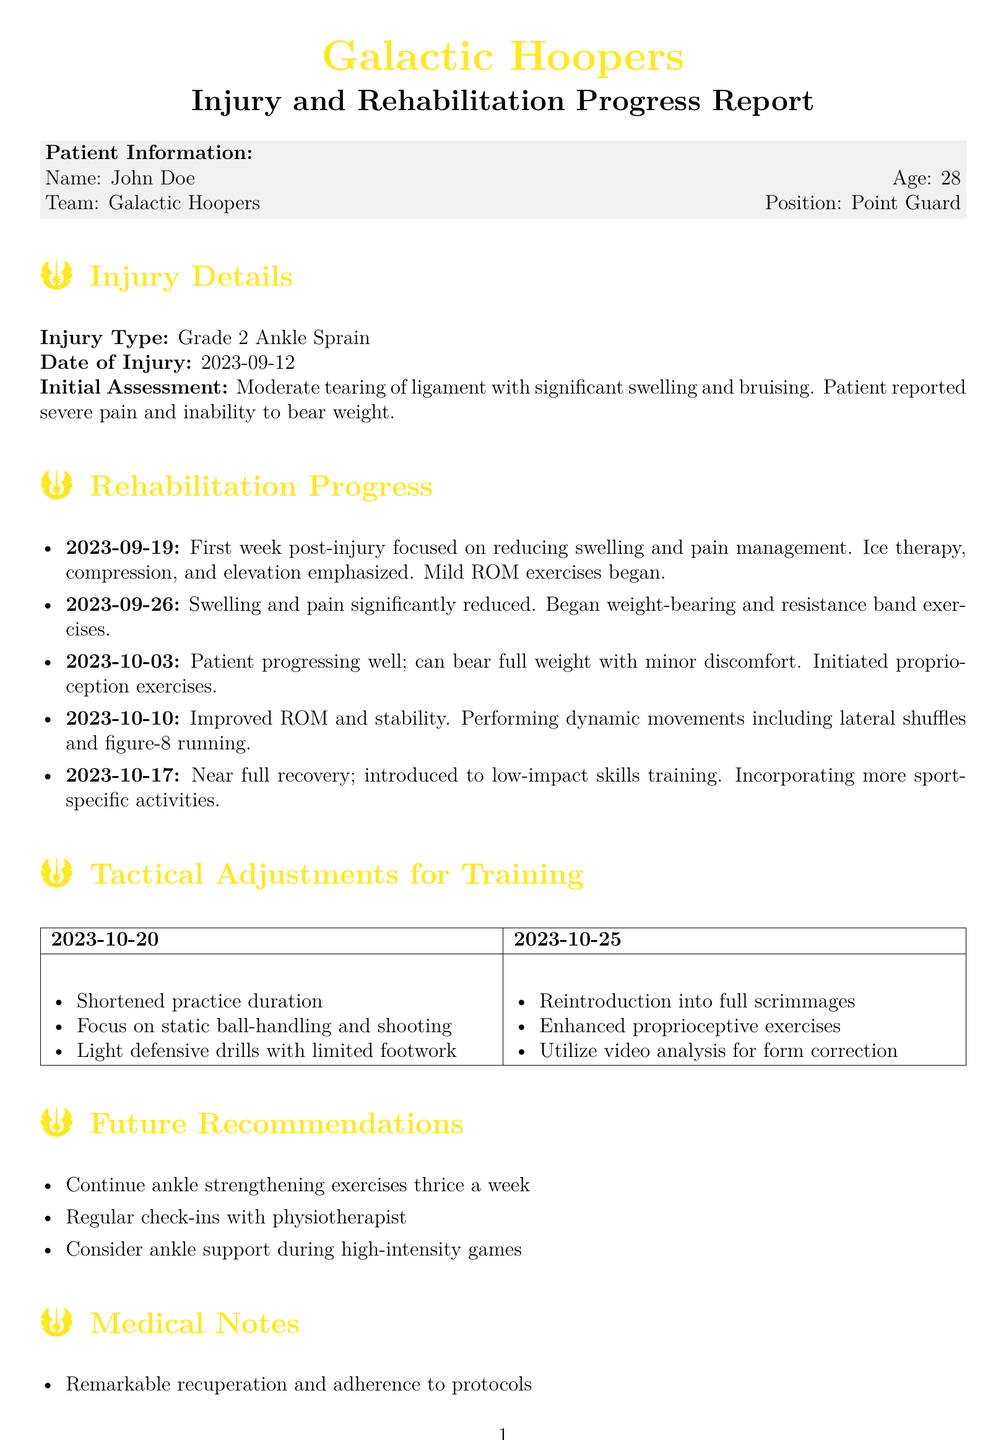What is the type of injury? The document states the injury type as "Grade 2 Ankle Sprain."
Answer: Grade 2 Ankle Sprain What date did the injury occur? The date of the injury is explicitly mentioned in the document as "2023-09-12."
Answer: 2023-09-12 What initial treatment was emphasized? The initial treatment for the injury focused on reducing swelling and pain management with ice therapy, compression, and elevation.
Answer: Ice therapy, compression, and elevation On which date did the patient initiate proprioception exercises? Proprioception exercises were initiated on "2023-10-03."
Answer: 2023-10-03 What was one of the tactical adjustments for training on 2023-10-20? The tactical adjustments for training on this date included "shortened practice duration."
Answer: Shortened practice duration What is the expected time for full recovery? According to the document, the expected time for full recovery is in "2 weeks."
Answer: 2 weeks What recommendation is made regarding ankle support during games? The recommendation mentioned in the document advises to "consider ankle support during high-intensity games."
Answer: Consider ankle support during high-intensity games What is the patient's age? The document provides the patient's age as "28."
Answer: 28 